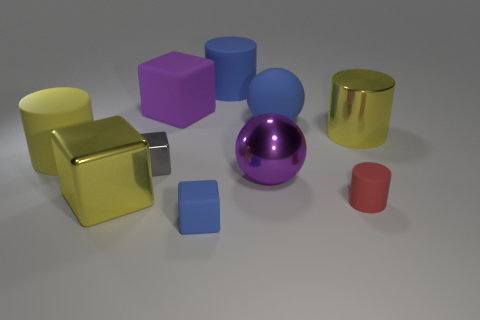Subtract all tiny cylinders. How many cylinders are left? 3 Subtract all gray blocks. How many blocks are left? 3 Subtract 2 cubes. How many cubes are left? 2 Subtract all cubes. How many objects are left? 6 Subtract all brown cylinders. Subtract all purple cubes. How many cylinders are left? 4 Subtract all purple spheres. How many yellow cylinders are left? 2 Subtract all purple rubber things. Subtract all small metal things. How many objects are left? 8 Add 6 gray metal things. How many gray metal things are left? 7 Add 5 red rubber things. How many red rubber things exist? 6 Subtract 1 blue blocks. How many objects are left? 9 